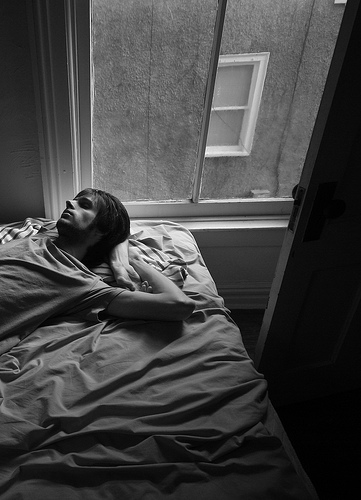What item of furniture is the guy lying in? The guy is lying in the bed. 